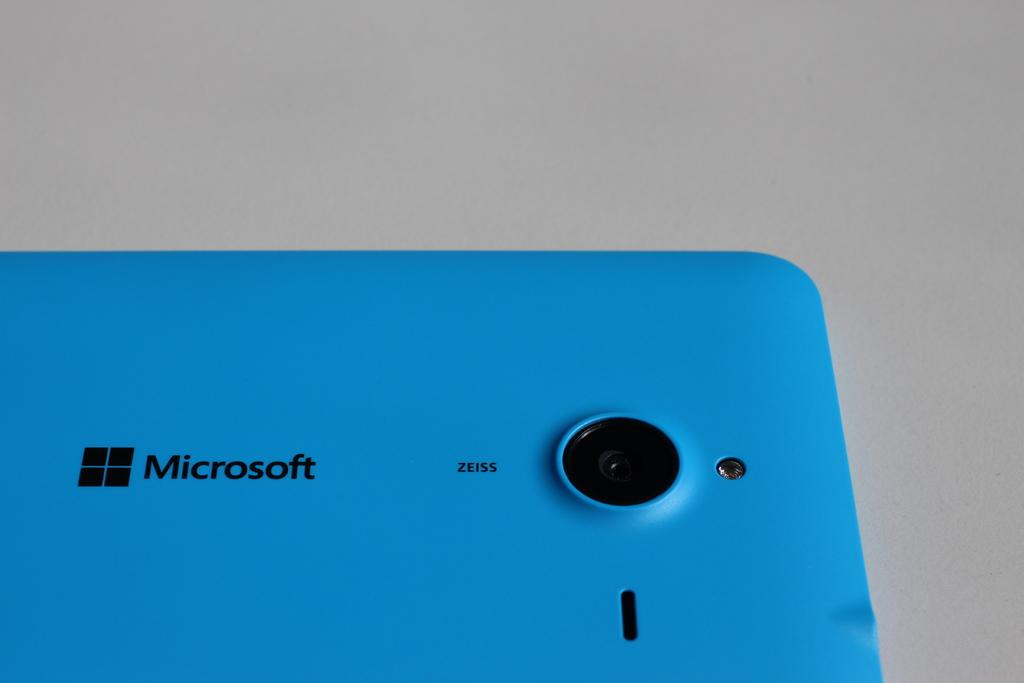<image>
Share a concise interpretation of the image provided. A blue Microsoft phone shows off its camera on the backside 